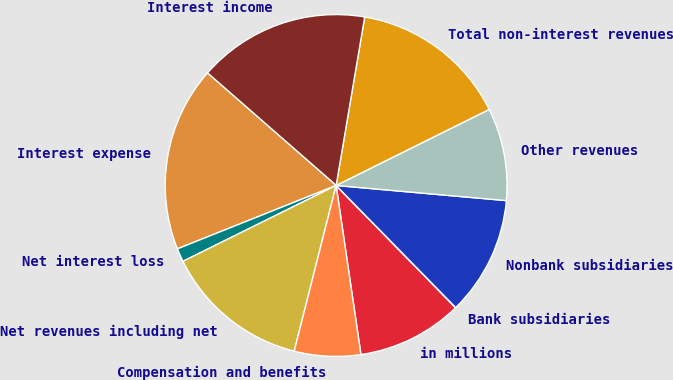Convert chart. <chart><loc_0><loc_0><loc_500><loc_500><pie_chart><fcel>in millions<fcel>Bank subsidiaries<fcel>Nonbank subsidiaries<fcel>Other revenues<fcel>Total non-interest revenues<fcel>Interest income<fcel>Interest expense<fcel>Net interest loss<fcel>Net revenues including net<fcel>Compensation and benefits<nl><fcel>10.0%<fcel>0.02%<fcel>11.25%<fcel>8.75%<fcel>14.99%<fcel>16.24%<fcel>17.48%<fcel>1.27%<fcel>13.74%<fcel>6.26%<nl></chart> 